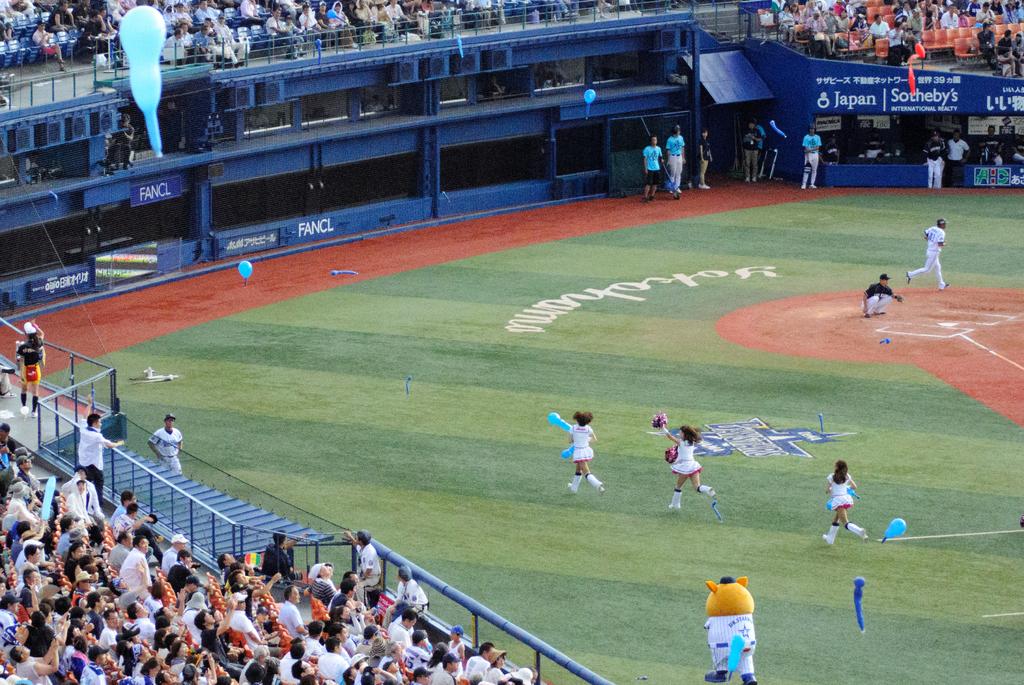What country is the baseball field in?
Your answer should be compact. Japan. Who advertises in this stadium?
Make the answer very short. Sotheby's. 